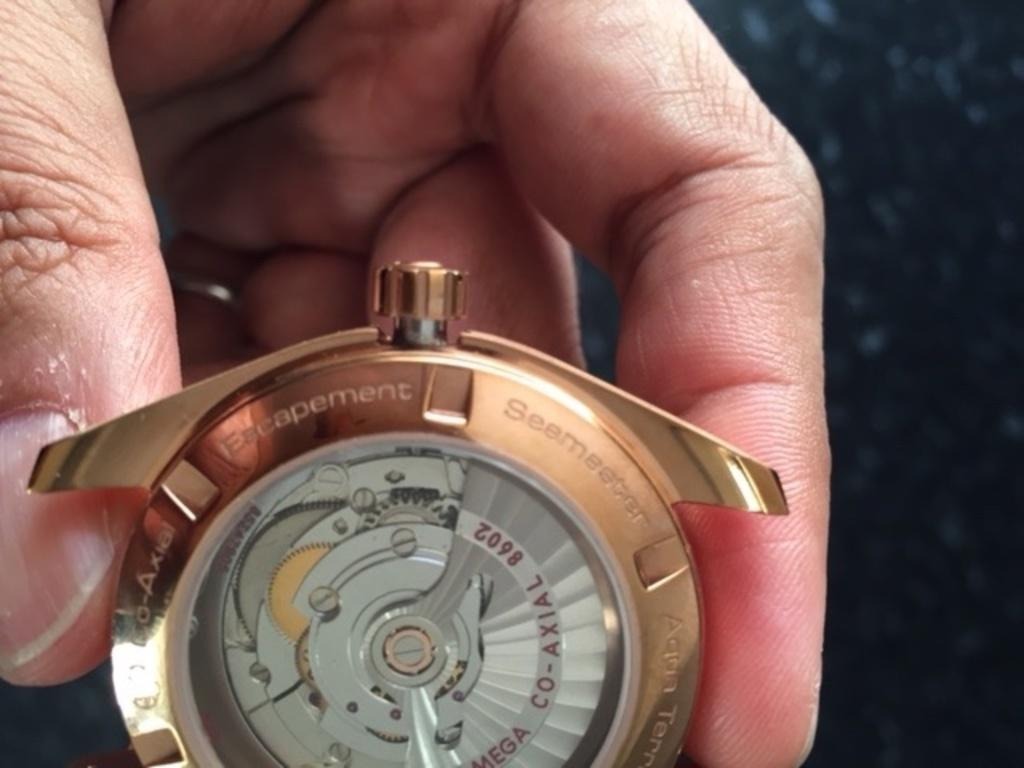Provide a one-sentence caption for the provided image. A THREE TONED GOLD AND SILVER  CO AXIAL WATCH. 